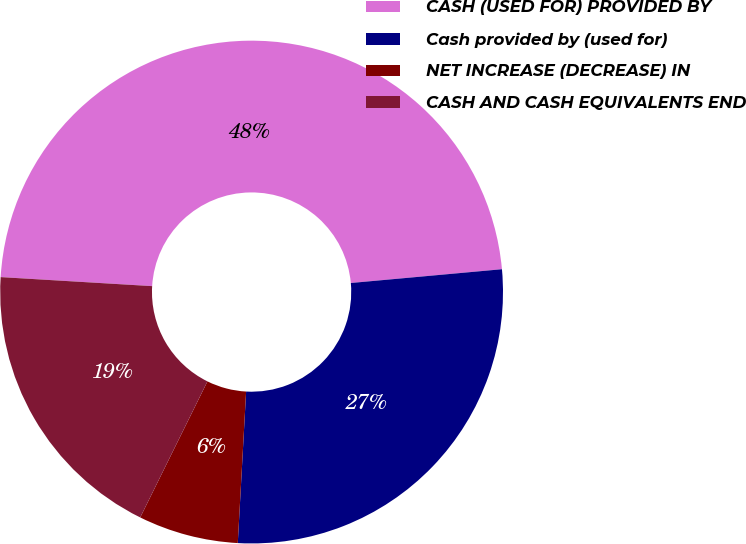<chart> <loc_0><loc_0><loc_500><loc_500><pie_chart><fcel>CASH (USED FOR) PROVIDED BY<fcel>Cash provided by (used for)<fcel>NET INCREASE (DECREASE) IN<fcel>CASH AND CASH EQUIVALENTS END<nl><fcel>47.6%<fcel>27.32%<fcel>6.43%<fcel>18.64%<nl></chart> 